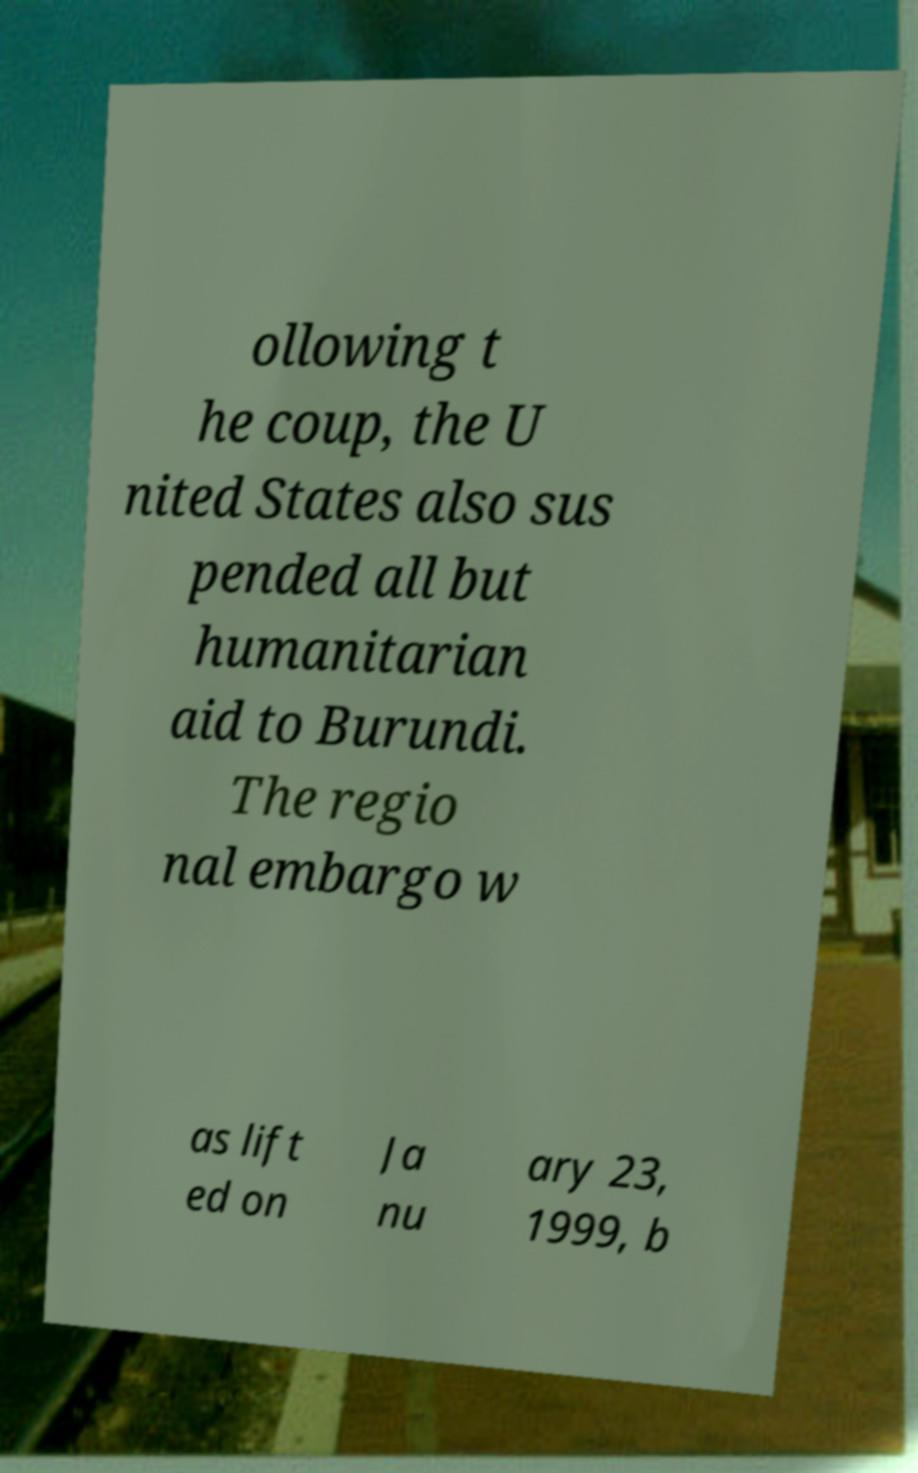Could you assist in decoding the text presented in this image and type it out clearly? ollowing t he coup, the U nited States also sus pended all but humanitarian aid to Burundi. The regio nal embargo w as lift ed on Ja nu ary 23, 1999, b 